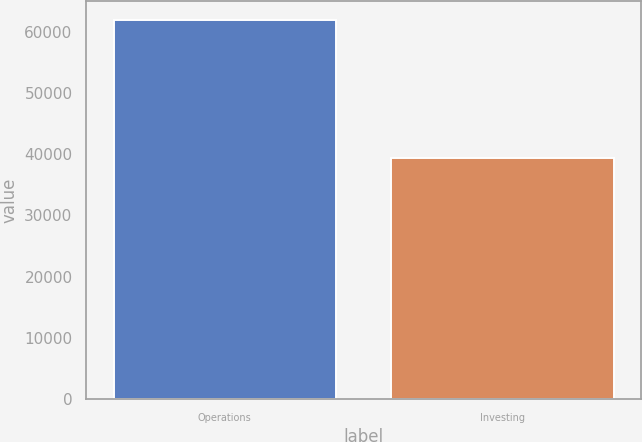Convert chart to OTSL. <chart><loc_0><loc_0><loc_500><loc_500><bar_chart><fcel>Operations<fcel>Investing<nl><fcel>61875<fcel>39373<nl></chart> 